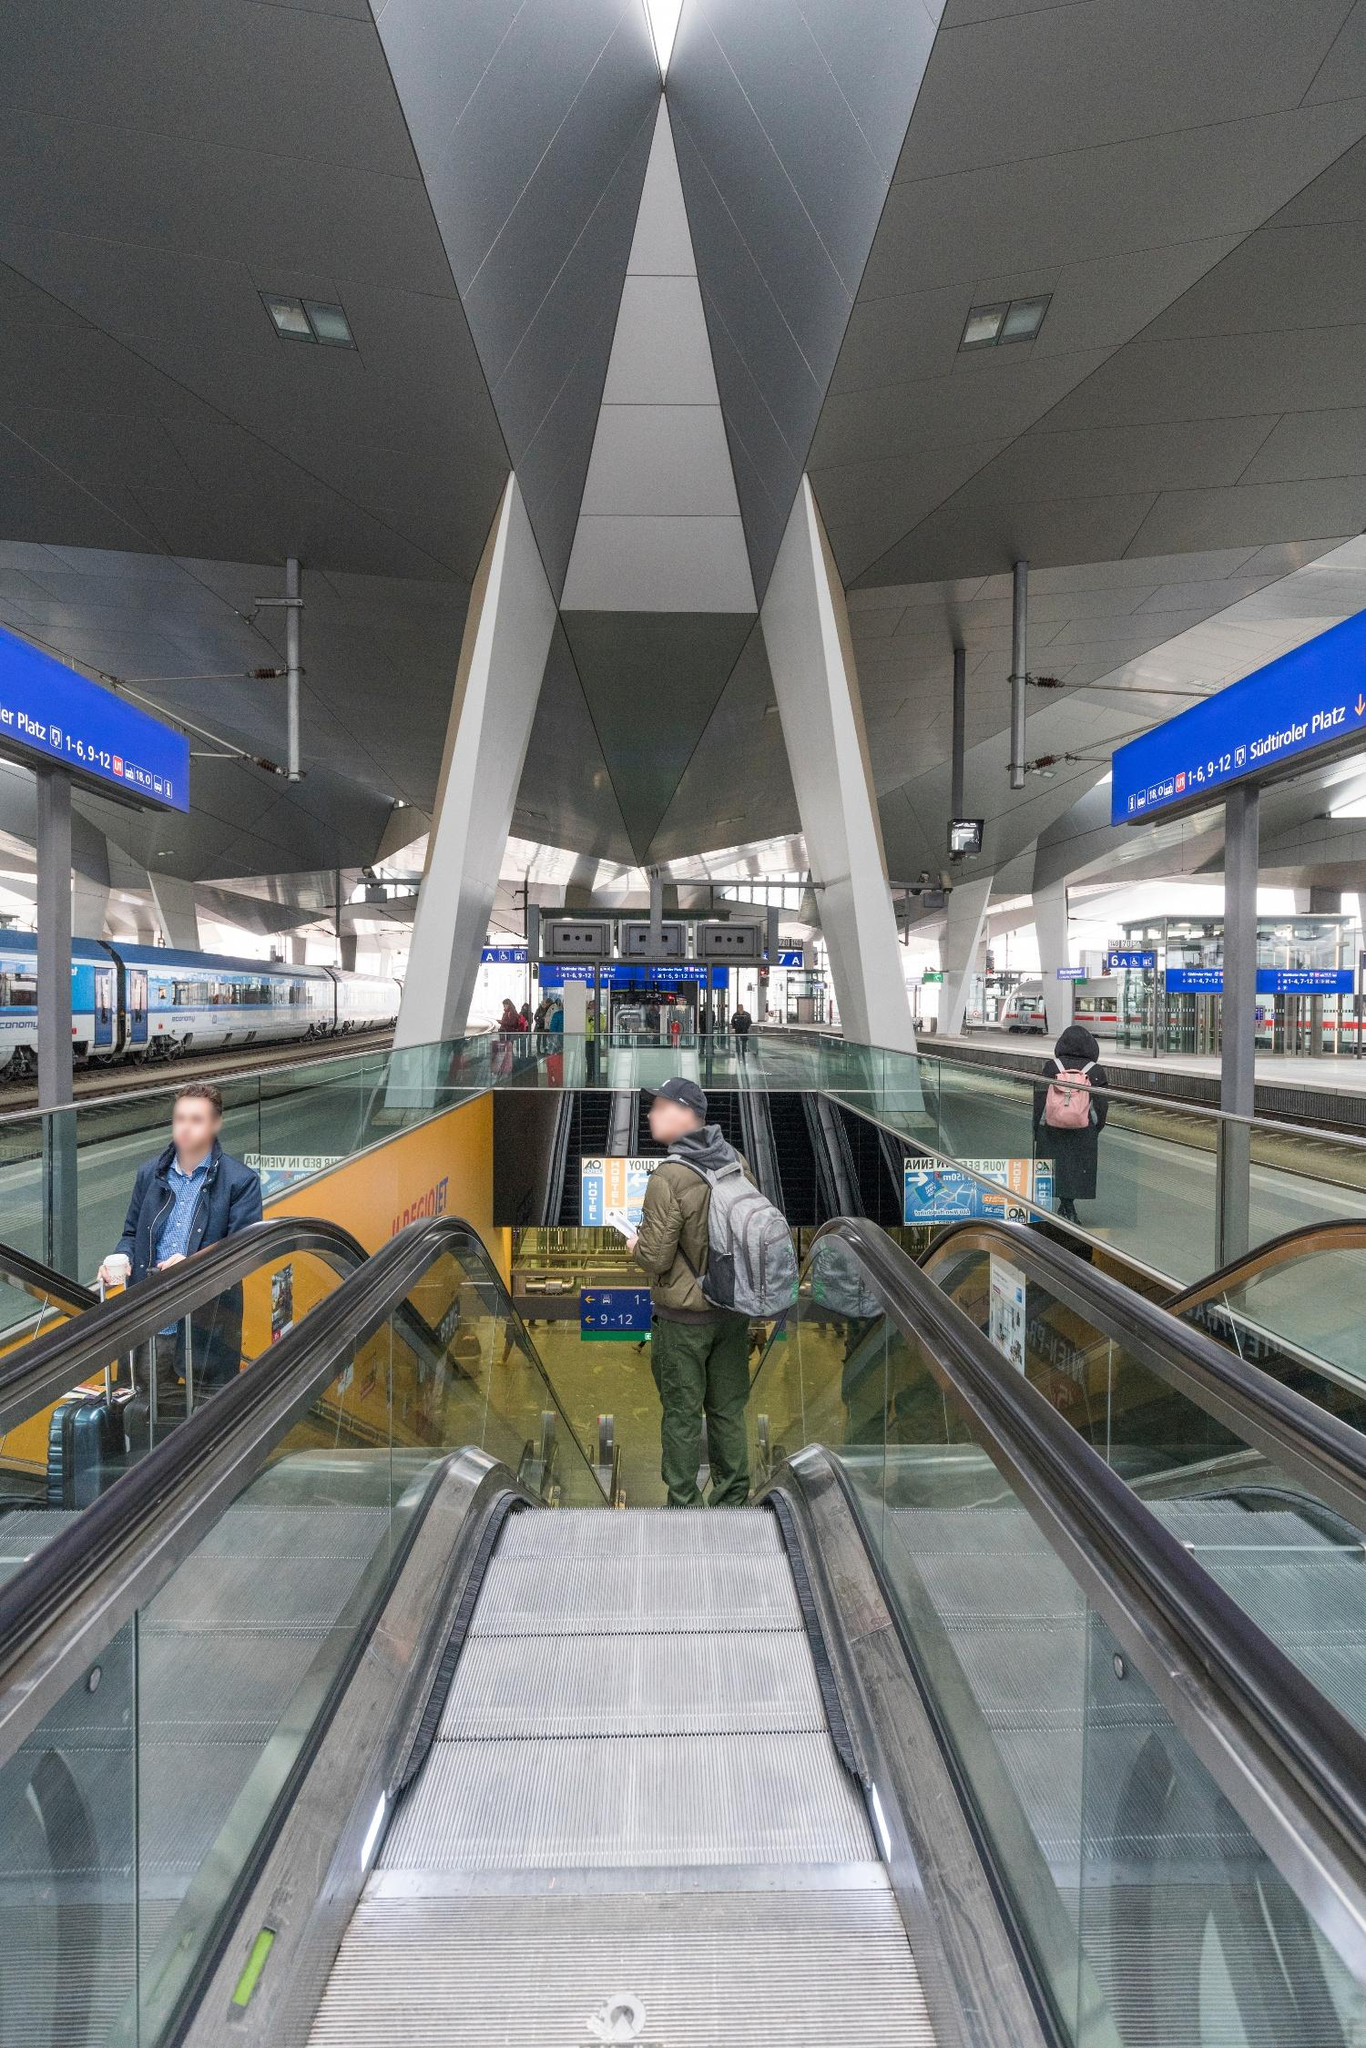Can you tell more about the design elements visible in this train station? Certainly! The train station incorporates predominantly modern architectural elements characterized by clean lines and stark geometric shapes. The metallic pillars, triangular in design, not only serve a structural purpose but also enhance the industrial aesthetic that's typical of modern transit hubs. The escalators, encased by these sharp-edged pillars, create a visually intriguing pathway leading the commuters into the belly of the station. Overhead, the ceiling panels appear to follow a subtle geometric pattern that complements the overall stark and streamlined motif. 